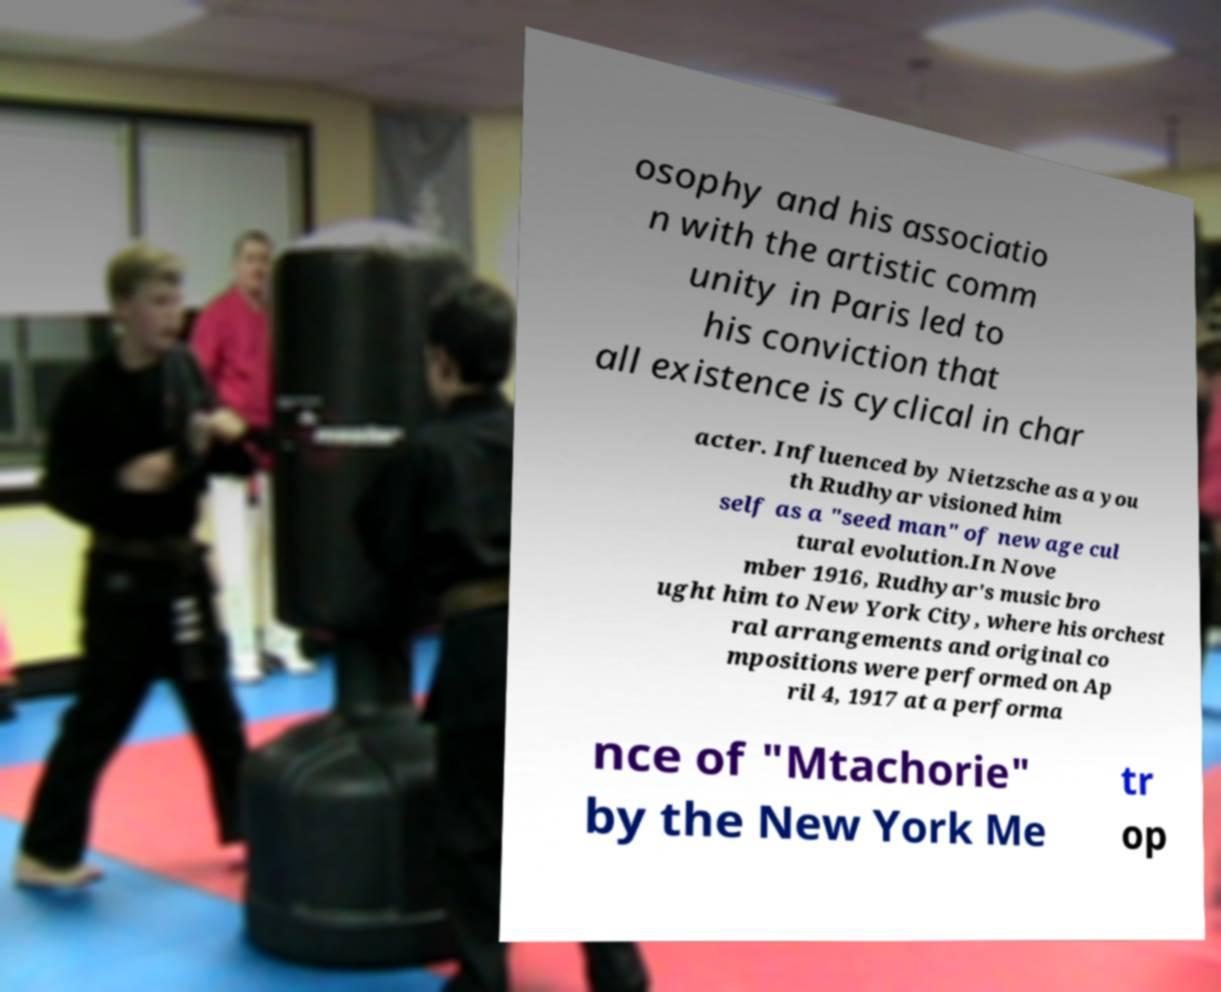There's text embedded in this image that I need extracted. Can you transcribe it verbatim? osophy and his associatio n with the artistic comm unity in Paris led to his conviction that all existence is cyclical in char acter. Influenced by Nietzsche as a you th Rudhyar visioned him self as a "seed man" of new age cul tural evolution.In Nove mber 1916, Rudhyar's music bro ught him to New York City, where his orchest ral arrangements and original co mpositions were performed on Ap ril 4, 1917 at a performa nce of "Mtachorie" by the New York Me tr op 